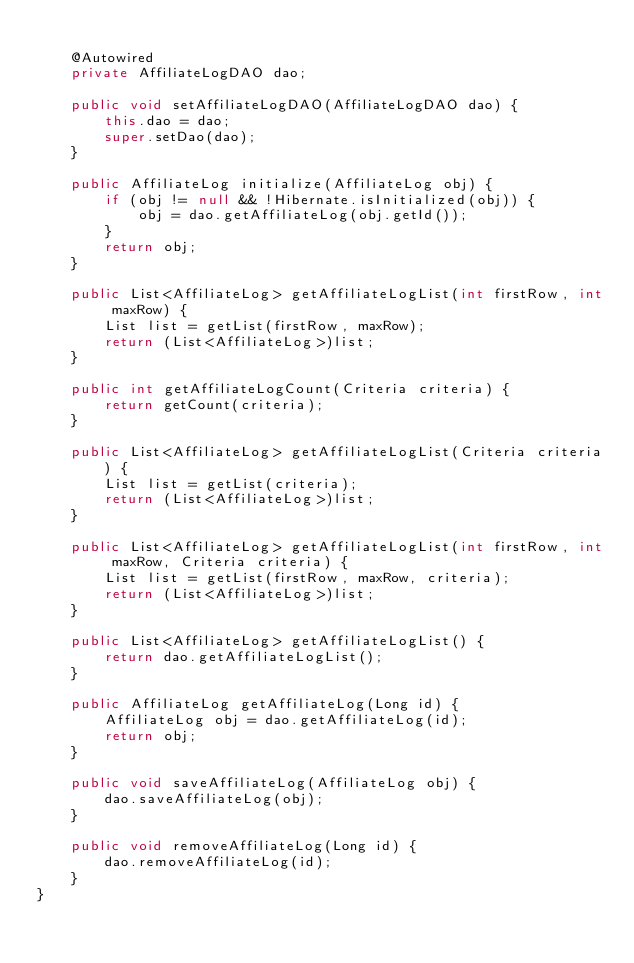Convert code to text. <code><loc_0><loc_0><loc_500><loc_500><_Java_>    
    @Autowired
    private AffiliateLogDAO dao;

    public void setAffiliateLogDAO(AffiliateLogDAO dao) {
        this.dao = dao;
        super.setDao(dao);
    }

    public AffiliateLog initialize(AffiliateLog obj) {
        if (obj != null && !Hibernate.isInitialized(obj)) {
            obj = dao.getAffiliateLog(obj.getId());
        }
        return obj;
    }

    public List<AffiliateLog> getAffiliateLogList(int firstRow, int maxRow) {
        List list = getList(firstRow, maxRow);
        return (List<AffiliateLog>)list;
    }

    public int getAffiliateLogCount(Criteria criteria) {
        return getCount(criteria);
    }

    public List<AffiliateLog> getAffiliateLogList(Criteria criteria) {
        List list = getList(criteria);
        return (List<AffiliateLog>)list;
    }

    public List<AffiliateLog> getAffiliateLogList(int firstRow, int maxRow, Criteria criteria) {
        List list = getList(firstRow, maxRow, criteria);
        return (List<AffiliateLog>)list;
    }

    public List<AffiliateLog> getAffiliateLogList() {
        return dao.getAffiliateLogList();
    }

    public AffiliateLog getAffiliateLog(Long id) {
        AffiliateLog obj = dao.getAffiliateLog(id);
        return obj;
    }

    public void saveAffiliateLog(AffiliateLog obj) {
        dao.saveAffiliateLog(obj);
    }

    public void removeAffiliateLog(Long id) {
        dao.removeAffiliateLog(id);
    }
}
</code> 